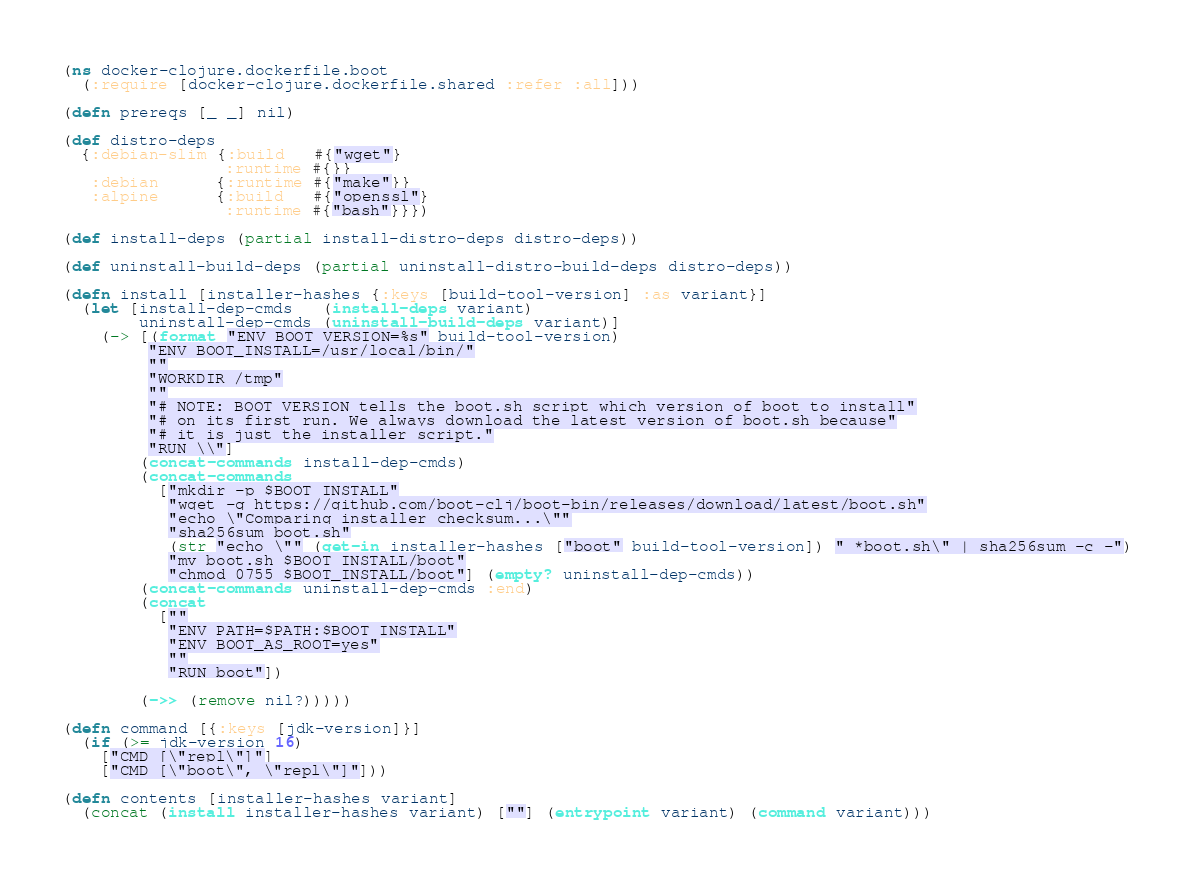Convert code to text. <code><loc_0><loc_0><loc_500><loc_500><_Clojure_>(ns docker-clojure.dockerfile.boot
  (:require [docker-clojure.dockerfile.shared :refer :all]))

(defn prereqs [_ _] nil)

(def distro-deps
  {:debian-slim {:build   #{"wget"}
                 :runtime #{}}
   :debian      {:runtime #{"make"}}
   :alpine      {:build   #{"openssl"}
                 :runtime #{"bash"}}})

(def install-deps (partial install-distro-deps distro-deps))

(def uninstall-build-deps (partial uninstall-distro-build-deps distro-deps))

(defn install [installer-hashes {:keys [build-tool-version] :as variant}]
  (let [install-dep-cmds   (install-deps variant)
        uninstall-dep-cmds (uninstall-build-deps variant)]
    (-> [(format "ENV BOOT_VERSION=%s" build-tool-version)
         "ENV BOOT_INSTALL=/usr/local/bin/"
         ""
         "WORKDIR /tmp"
         ""
         "# NOTE: BOOT_VERSION tells the boot.sh script which version of boot to install"
         "# on its first run. We always download the latest version of boot.sh because"
         "# it is just the installer script."
         "RUN \\"]
        (concat-commands install-dep-cmds)
        (concat-commands
          ["mkdir -p $BOOT_INSTALL"
           "wget -q https://github.com/boot-clj/boot-bin/releases/download/latest/boot.sh"
           "echo \"Comparing installer checksum...\""
           "sha256sum boot.sh"
           (str "echo \"" (get-in installer-hashes ["boot" build-tool-version]) " *boot.sh\" | sha256sum -c -")
           "mv boot.sh $BOOT_INSTALL/boot"
           "chmod 0755 $BOOT_INSTALL/boot"] (empty? uninstall-dep-cmds))
        (concat-commands uninstall-dep-cmds :end)
        (concat
          [""
           "ENV PATH=$PATH:$BOOT_INSTALL"
           "ENV BOOT_AS_ROOT=yes"
           ""
           "RUN boot"])

        (->> (remove nil?)))))

(defn command [{:keys [jdk-version]}]
  (if (>= jdk-version 16)
    ["CMD [\"repl\"]"]
    ["CMD [\"boot\", \"repl\"]"]))

(defn contents [installer-hashes variant]
  (concat (install installer-hashes variant) [""] (entrypoint variant) (command variant)))
</code> 